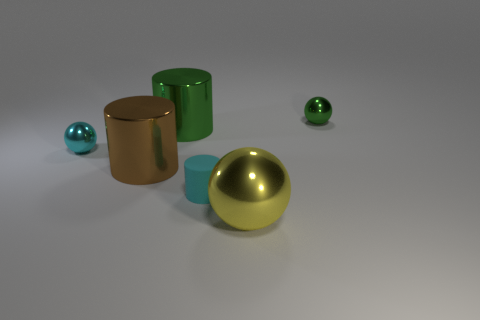Do the tiny matte cylinder and the shiny ball that is to the left of the cyan rubber cylinder have the same color? yes 